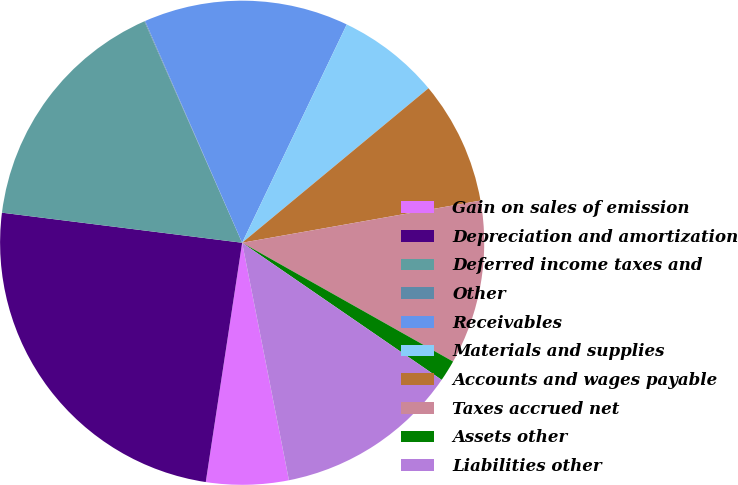<chart> <loc_0><loc_0><loc_500><loc_500><pie_chart><fcel>Gain on sales of emission<fcel>Depreciation and amortization<fcel>Deferred income taxes and<fcel>Other<fcel>Receivables<fcel>Materials and supplies<fcel>Accounts and wages payable<fcel>Taxes accrued net<fcel>Assets other<fcel>Liabilities other<nl><fcel>5.5%<fcel>24.58%<fcel>16.4%<fcel>0.05%<fcel>13.68%<fcel>6.87%<fcel>8.23%<fcel>10.95%<fcel>1.42%<fcel>12.32%<nl></chart> 